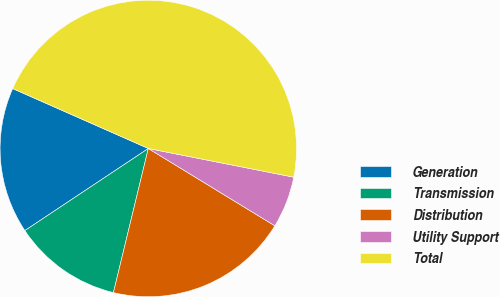Convert chart. <chart><loc_0><loc_0><loc_500><loc_500><pie_chart><fcel>Generation<fcel>Transmission<fcel>Distribution<fcel>Utility Support<fcel>Total<nl><fcel>15.96%<fcel>11.88%<fcel>20.05%<fcel>5.63%<fcel>46.48%<nl></chart> 